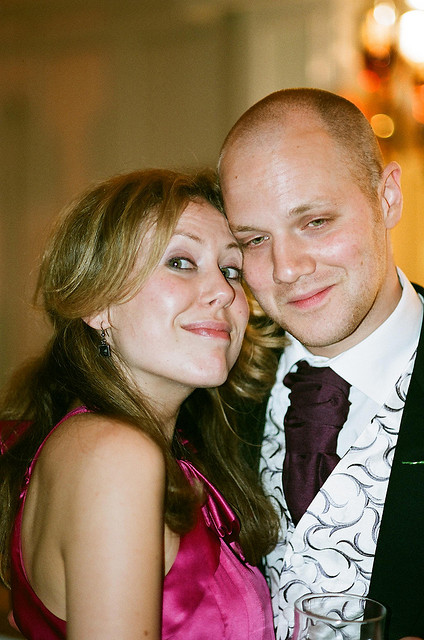<image>What pattern is the tie that the gentleman is wearing? I don't know the exact pattern of the tie. However, it appears to be a solid or plain pattern. What pattern is the tie that the gentleman is wearing? I am not sure about the pattern of the tie that the gentleman is wearing. It can be either plain, solid, or have no pattern. 